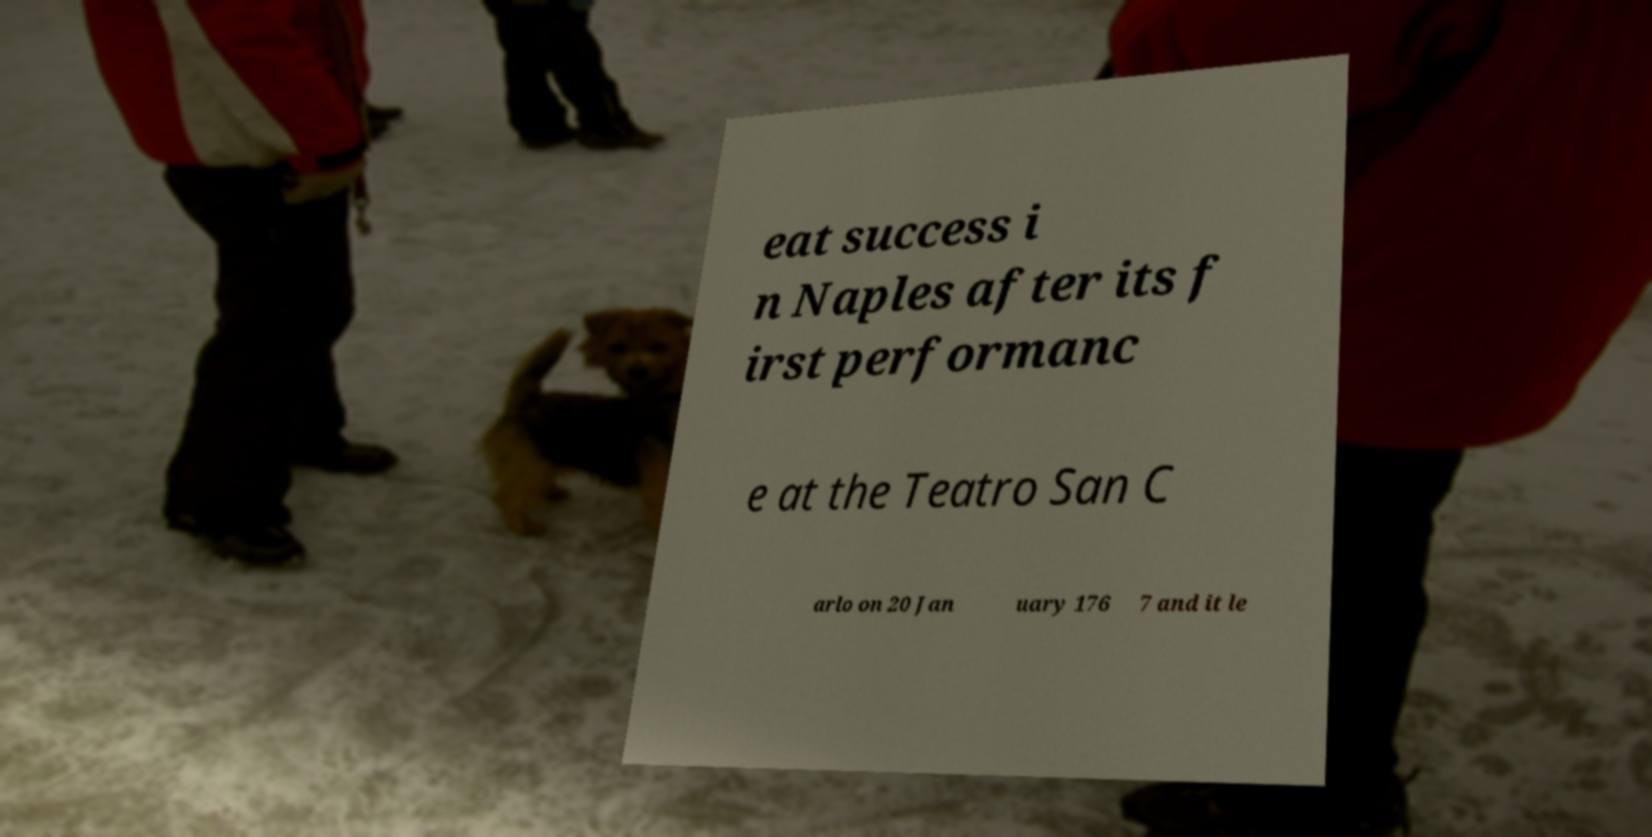I need the written content from this picture converted into text. Can you do that? eat success i n Naples after its f irst performanc e at the Teatro San C arlo on 20 Jan uary 176 7 and it le 